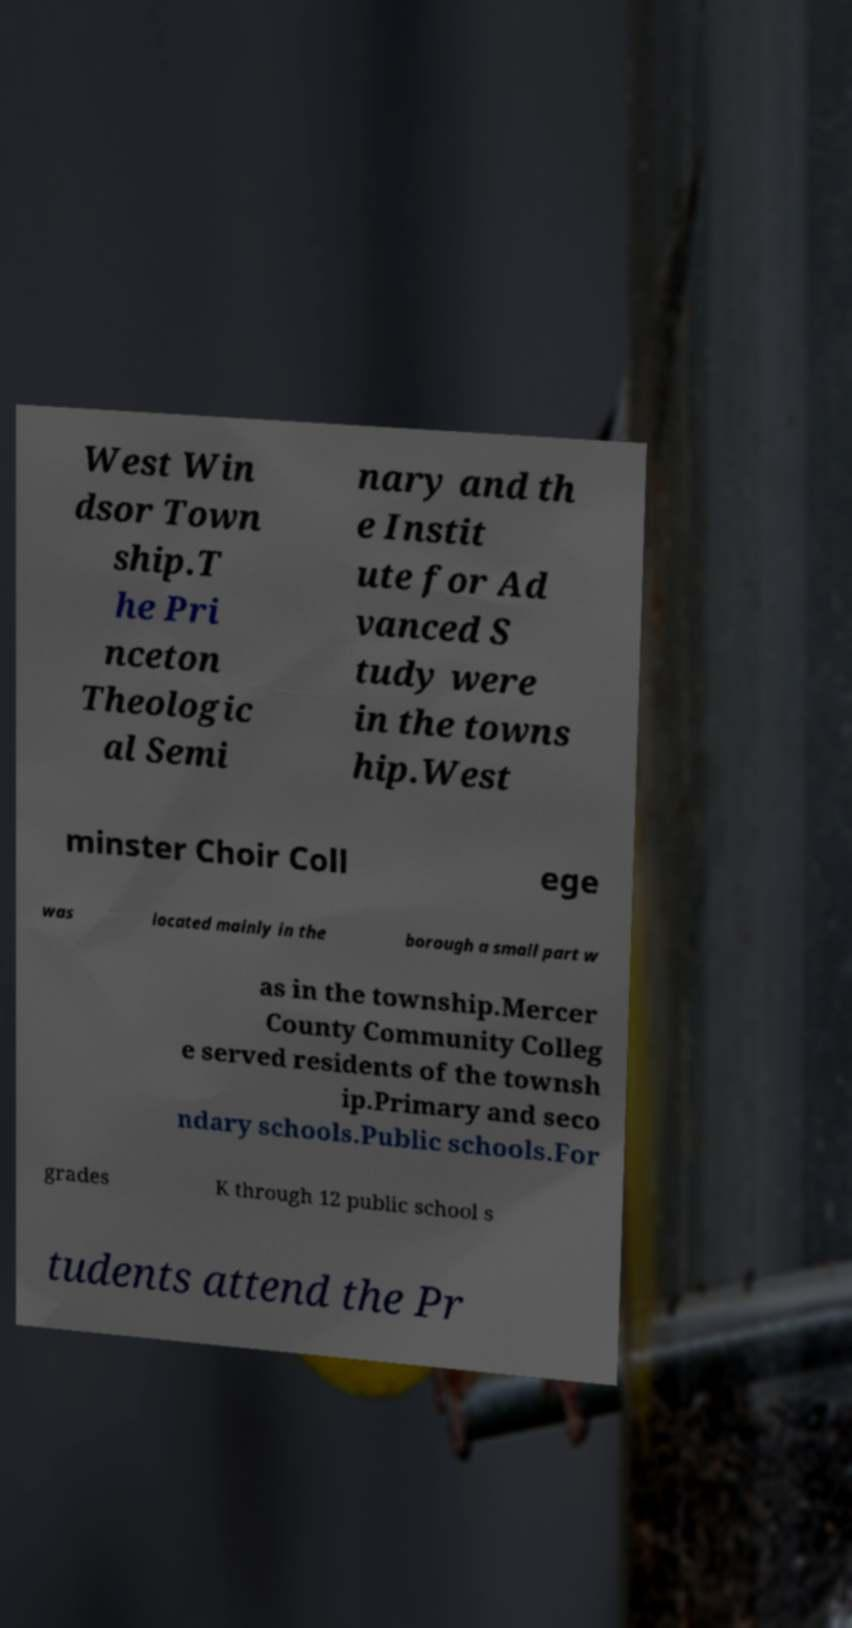Could you extract and type out the text from this image? West Win dsor Town ship.T he Pri nceton Theologic al Semi nary and th e Instit ute for Ad vanced S tudy were in the towns hip.West minster Choir Coll ege was located mainly in the borough a small part w as in the township.Mercer County Community Colleg e served residents of the townsh ip.Primary and seco ndary schools.Public schools.For grades K through 12 public school s tudents attend the Pr 